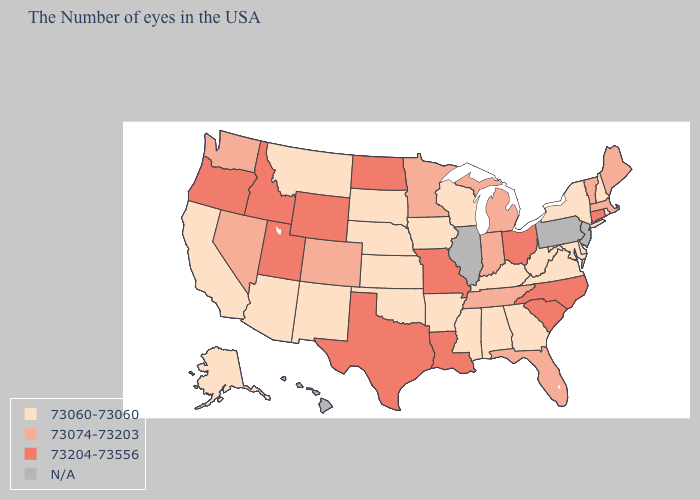What is the lowest value in states that border Arkansas?
Be succinct. 73060-73060. Name the states that have a value in the range 73060-73060?
Write a very short answer. Rhode Island, New Hampshire, New York, Delaware, Maryland, Virginia, West Virginia, Georgia, Kentucky, Alabama, Wisconsin, Mississippi, Arkansas, Iowa, Kansas, Nebraska, Oklahoma, South Dakota, New Mexico, Montana, Arizona, California, Alaska. What is the value of Georgia?
Concise answer only. 73060-73060. What is the value of Iowa?
Give a very brief answer. 73060-73060. What is the highest value in the South ?
Concise answer only. 73204-73556. Among the states that border Connecticut , does New York have the highest value?
Quick response, please. No. Name the states that have a value in the range 73074-73203?
Concise answer only. Maine, Massachusetts, Vermont, Florida, Michigan, Indiana, Tennessee, Minnesota, Colorado, Nevada, Washington. Which states have the lowest value in the West?
Write a very short answer. New Mexico, Montana, Arizona, California, Alaska. What is the value of New Hampshire?
Keep it brief. 73060-73060. Does Maine have the highest value in the Northeast?
Write a very short answer. No. What is the highest value in the USA?
Answer briefly. 73204-73556. What is the lowest value in the Northeast?
Short answer required. 73060-73060. Among the states that border Texas , does Arkansas have the highest value?
Give a very brief answer. No. Does the first symbol in the legend represent the smallest category?
Quick response, please. Yes. 